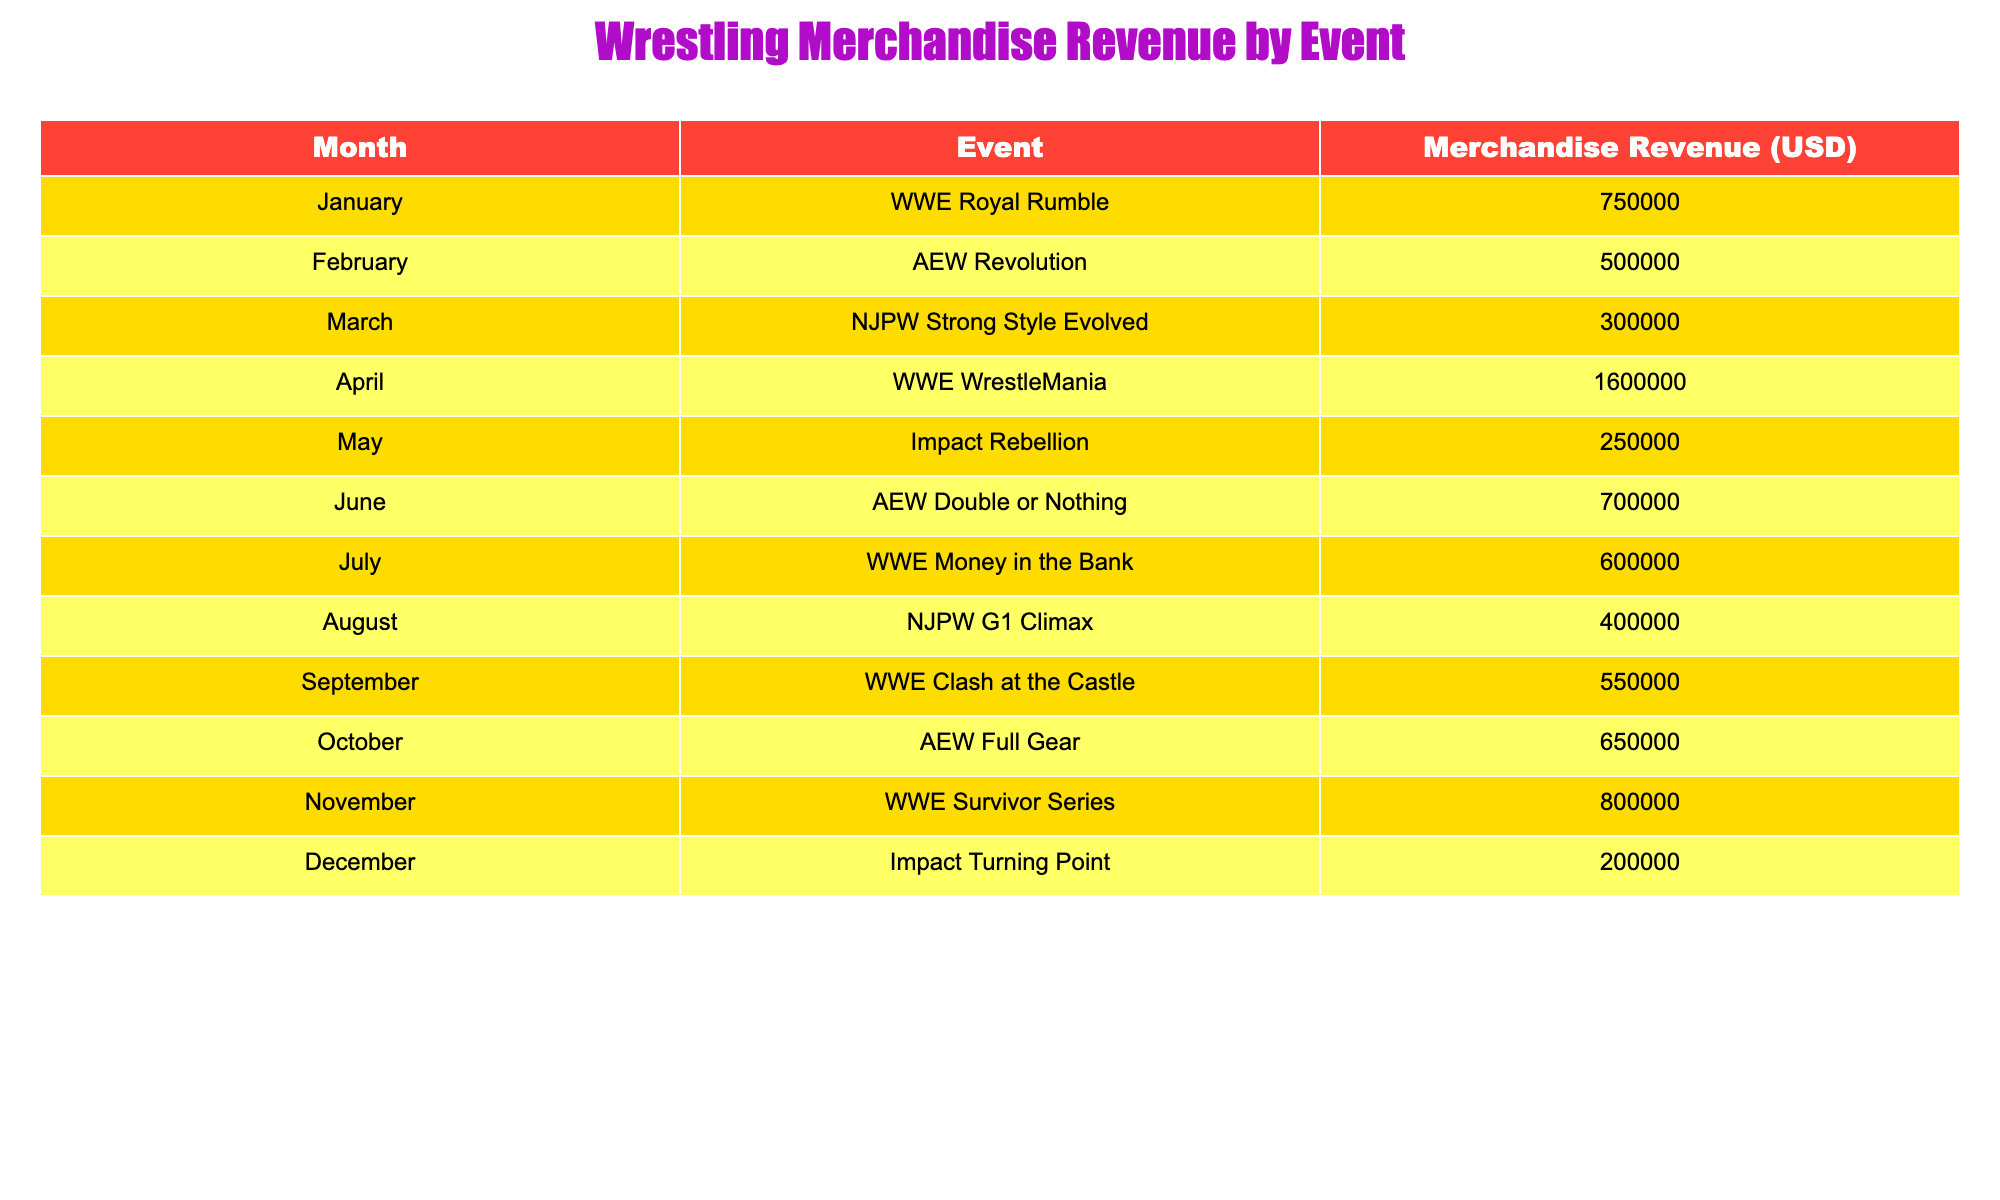What is the total merchandise revenue generated in April? The table shows that in April, the merchandise revenue for WWE WrestleMania is 1,600,000 USD. Since this is the only row for that month, the total revenue is simply this value.
Answer: 1,600,000 USD Which event generated the highest merchandise revenue? By examining the table, we see that WWE WrestleMania in April generated the most revenue at 1,600,000 USD.
Answer: WWE WrestleMania What is the average merchandise revenue for all events? To find the average revenue, I will sum all the revenue values: 750,000 + 500,000 + 300,000 + 1,600,000 + 250,000 + 700,000 + 600,000 + 400,000 + 550,000 + 650,000 + 800,000 + 200,000 = 6,750,000 USD. There are 12 events, so the average revenue is 6,750,000 / 12 = 562,500 USD.
Answer: 562,500 USD Did Impact Rebellion generate more than 300,000 USD in merchandise revenue? Referring to the table, Impact Rebellion generated 250,000 USD. Since 250,000 is less than 300,000, the statement is false.
Answer: No What is the total merchandise revenue generated in the second half of the year? The second half of the year includes July, August, September, October, November, and December. Summing those values gives: 600,000 (July) + 400,000 (August) + 550,000 (September) + 650,000 (October) + 800,000 (November) + 200,000 (December) = 3,250,000 USD.
Answer: 3,250,000 USD Which two events had revenue close to 500,000 USD? Looking at the table, AEW Revolution in February had 500,000 USD, and NJPW G1 Climax in August had 400,000 USD. While only AEW Revolution matches 500,000 pattern, none other is close enough to be a second match.
Answer: One event matches, no close second 